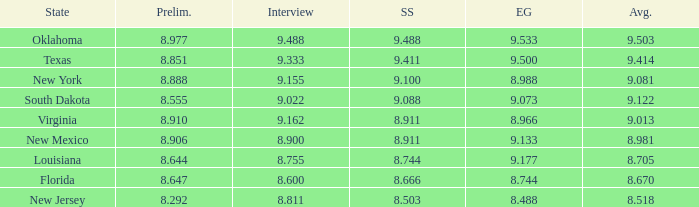Parse the table in full. {'header': ['State', 'Prelim.', 'Interview', 'SS', 'EG', 'Avg.'], 'rows': [['Oklahoma', '8.977', '9.488', '9.488', '9.533', '9.503'], ['Texas', '8.851', '9.333', '9.411', '9.500', '9.414'], ['New York', '8.888', '9.155', '9.100', '8.988', '9.081'], ['South Dakota', '8.555', '9.022', '9.088', '9.073', '9.122'], ['Virginia', '8.910', '9.162', '8.911', '8.966', '9.013'], ['New Mexico', '8.906', '8.900', '8.911', '9.133', '8.981'], ['Louisiana', '8.644', '8.755', '8.744', '9.177', '8.705'], ['Florida', '8.647', '8.600', '8.666', '8.744', '8.670'], ['New Jersey', '8.292', '8.811', '8.503', '8.488', '8.518']]}  what's the preliminaries where state is south dakota 8.555. 